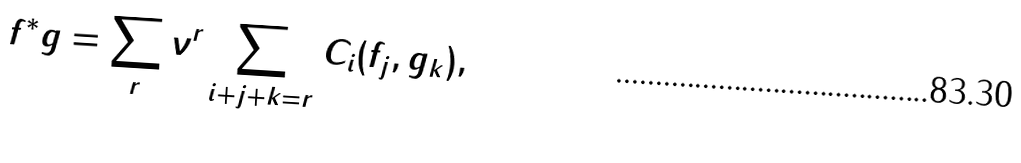Convert formula to latex. <formula><loc_0><loc_0><loc_500><loc_500>f ^ { * } g = \sum _ { r } \nu ^ { r } \sum _ { i + j + k = r } C _ { i } ( f _ { j } , g _ { k } ) ,</formula> 